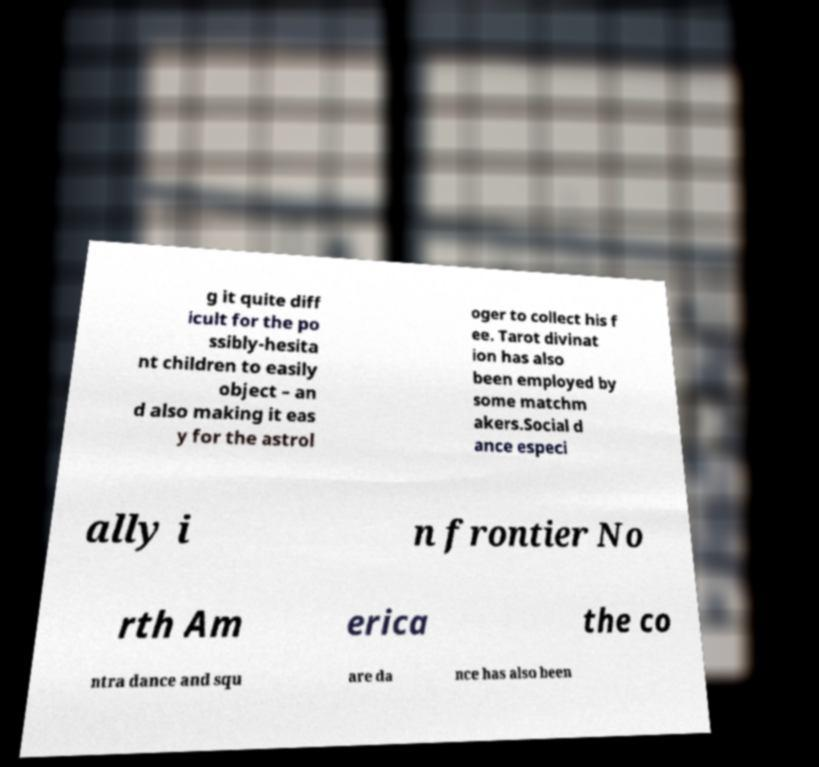There's text embedded in this image that I need extracted. Can you transcribe it verbatim? g it quite diff icult for the po ssibly-hesita nt children to easily object – an d also making it eas y for the astrol oger to collect his f ee. Tarot divinat ion has also been employed by some matchm akers.Social d ance especi ally i n frontier No rth Am erica the co ntra dance and squ are da nce has also been 